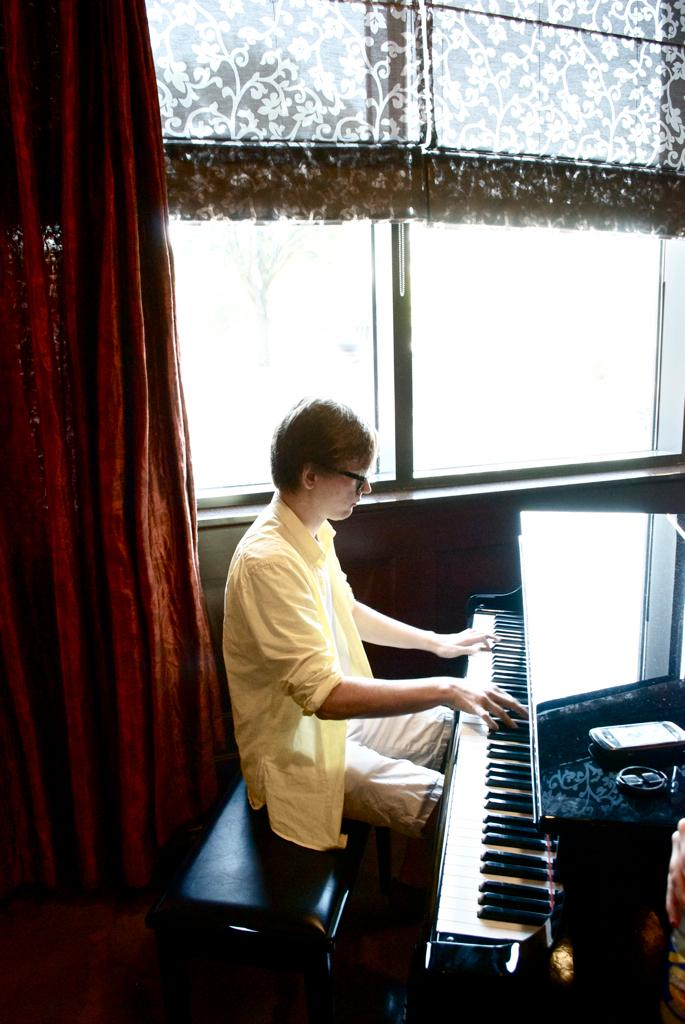What is the person in the image doing? The person is playing a grand piano. What can be seen hanging in the image? There is a mobile in the image. What is the object in the image? There is an object in the image, but the specific nature of the object is not mentioned in the facts. What is visible through the window in the image? The facts do not mention what can be seen through the window. What type of window treatment is present in the image? There are curtains associated with the window in the image. What type of nail is being used to play the grand piano in the image? There is no mention of a nail being used to play the grand piano in the image. The person is using their hands to play the piano. 